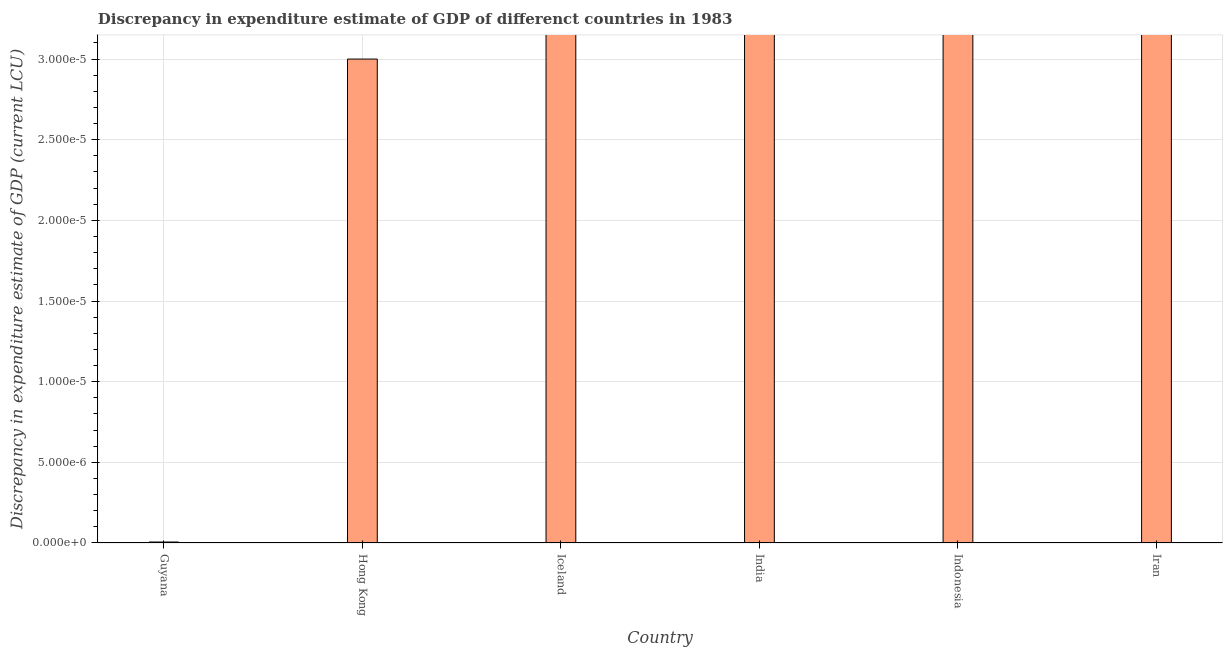Does the graph contain any zero values?
Give a very brief answer. Yes. Does the graph contain grids?
Offer a very short reply. Yes. What is the title of the graph?
Provide a succinct answer. Discrepancy in expenditure estimate of GDP of differenct countries in 1983. What is the label or title of the Y-axis?
Your answer should be very brief. Discrepancy in expenditure estimate of GDP (current LCU). What is the discrepancy in expenditure estimate of gdp in Hong Kong?
Provide a succinct answer. 3e-5. Across all countries, what is the maximum discrepancy in expenditure estimate of gdp?
Provide a succinct answer. 3e-5. Across all countries, what is the minimum discrepancy in expenditure estimate of gdp?
Provide a short and direct response. 0. In which country was the discrepancy in expenditure estimate of gdp maximum?
Give a very brief answer. Hong Kong. What is the sum of the discrepancy in expenditure estimate of gdp?
Your answer should be very brief. 3.006e-5. What is the difference between the discrepancy in expenditure estimate of gdp in Guyana and Hong Kong?
Provide a succinct answer. -0. What is the average discrepancy in expenditure estimate of gdp per country?
Make the answer very short. 0. What is the median discrepancy in expenditure estimate of gdp?
Provide a succinct answer. 0. In how many countries, is the discrepancy in expenditure estimate of gdp greater than 1.9e-05 LCU?
Your answer should be very brief. 1. Is the sum of the discrepancy in expenditure estimate of gdp in Guyana and Hong Kong greater than the maximum discrepancy in expenditure estimate of gdp across all countries?
Provide a succinct answer. Yes. What is the difference between the highest and the lowest discrepancy in expenditure estimate of gdp?
Make the answer very short. 0. In how many countries, is the discrepancy in expenditure estimate of gdp greater than the average discrepancy in expenditure estimate of gdp taken over all countries?
Make the answer very short. 1. How many countries are there in the graph?
Your response must be concise. 6. What is the difference between two consecutive major ticks on the Y-axis?
Your response must be concise. 5e-6. What is the Discrepancy in expenditure estimate of GDP (current LCU) of Guyana?
Your answer should be very brief. 6e-8. What is the Discrepancy in expenditure estimate of GDP (current LCU) of Hong Kong?
Provide a succinct answer. 3e-5. What is the Discrepancy in expenditure estimate of GDP (current LCU) of Iceland?
Provide a short and direct response. 0. What is the Discrepancy in expenditure estimate of GDP (current LCU) of India?
Offer a terse response. 0. What is the difference between the Discrepancy in expenditure estimate of GDP (current LCU) in Guyana and Hong Kong?
Make the answer very short. -3e-5. What is the ratio of the Discrepancy in expenditure estimate of GDP (current LCU) in Guyana to that in Hong Kong?
Your answer should be very brief. 0. 